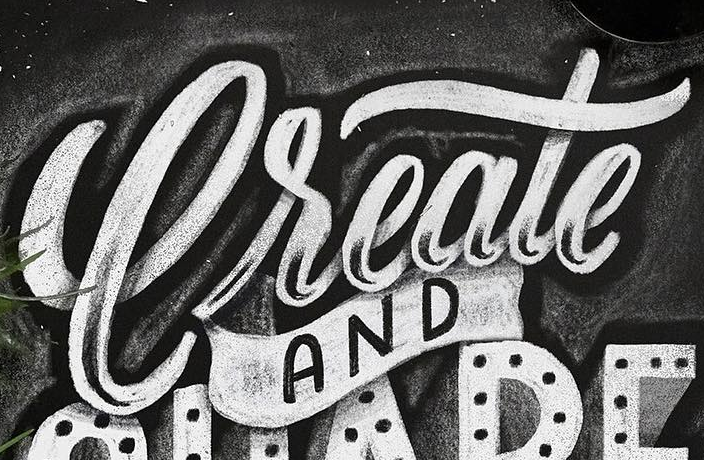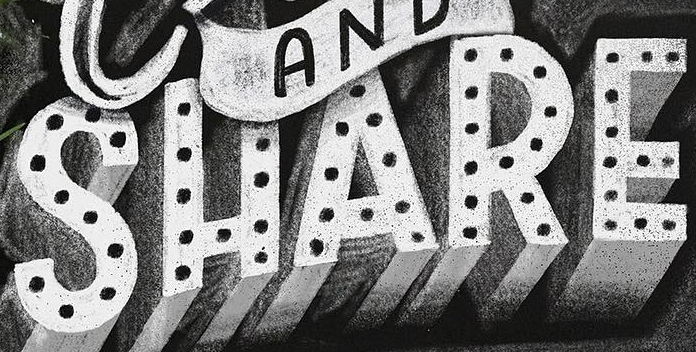Identify the words shown in these images in order, separated by a semicolon. Create; SHARE 